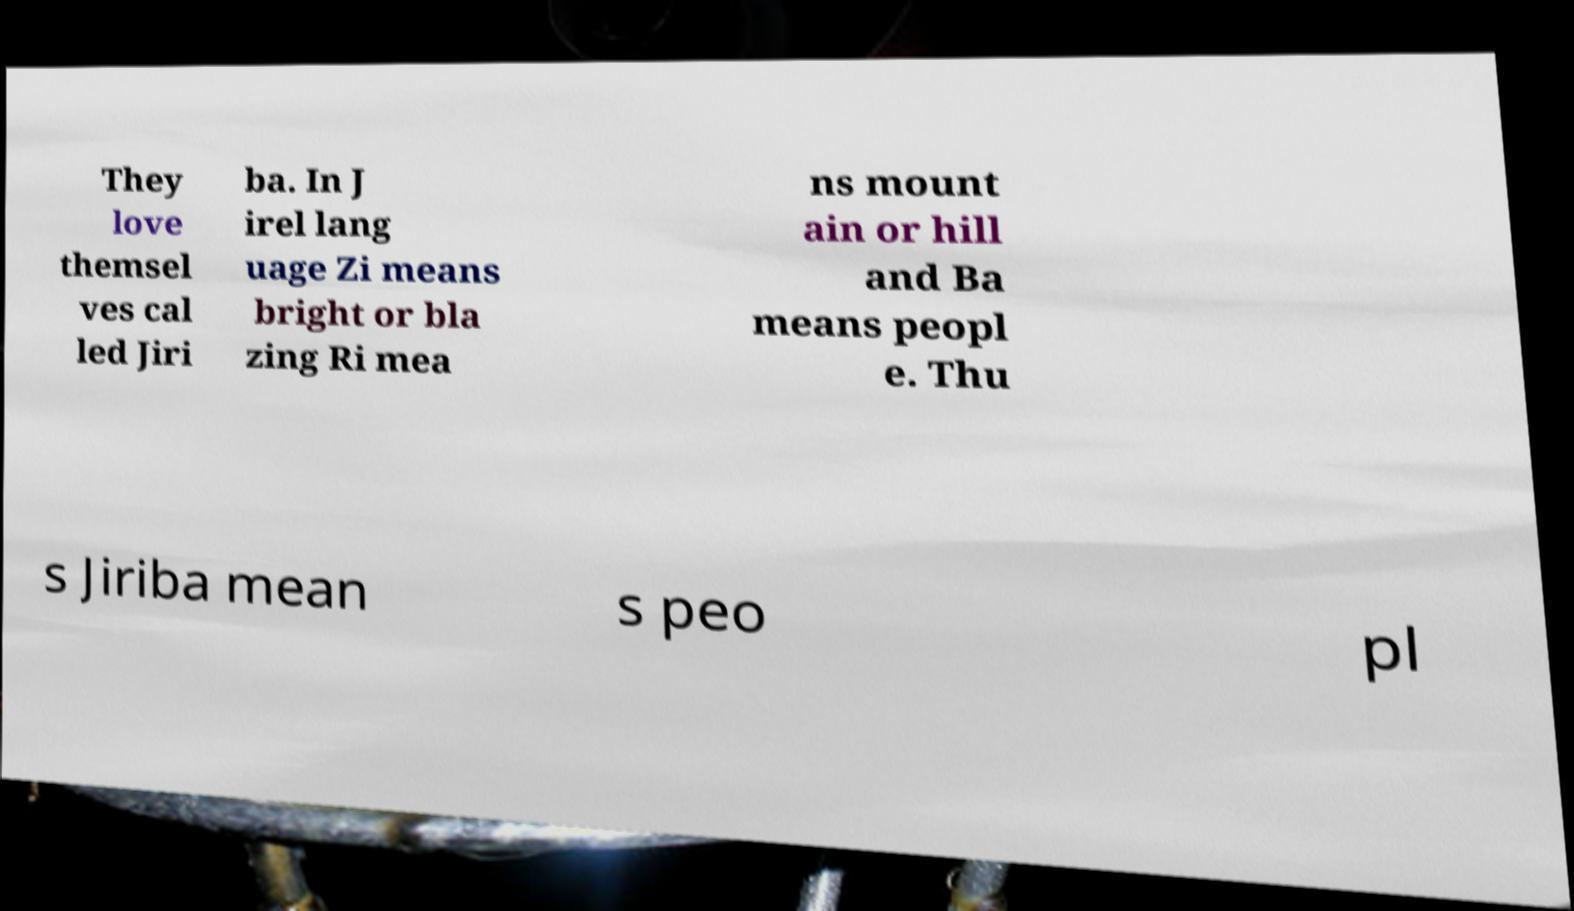I need the written content from this picture converted into text. Can you do that? They love themsel ves cal led Jiri ba. In J irel lang uage Zi means bright or bla zing Ri mea ns mount ain or hill and Ba means peopl e. Thu s Jiriba mean s peo pl 